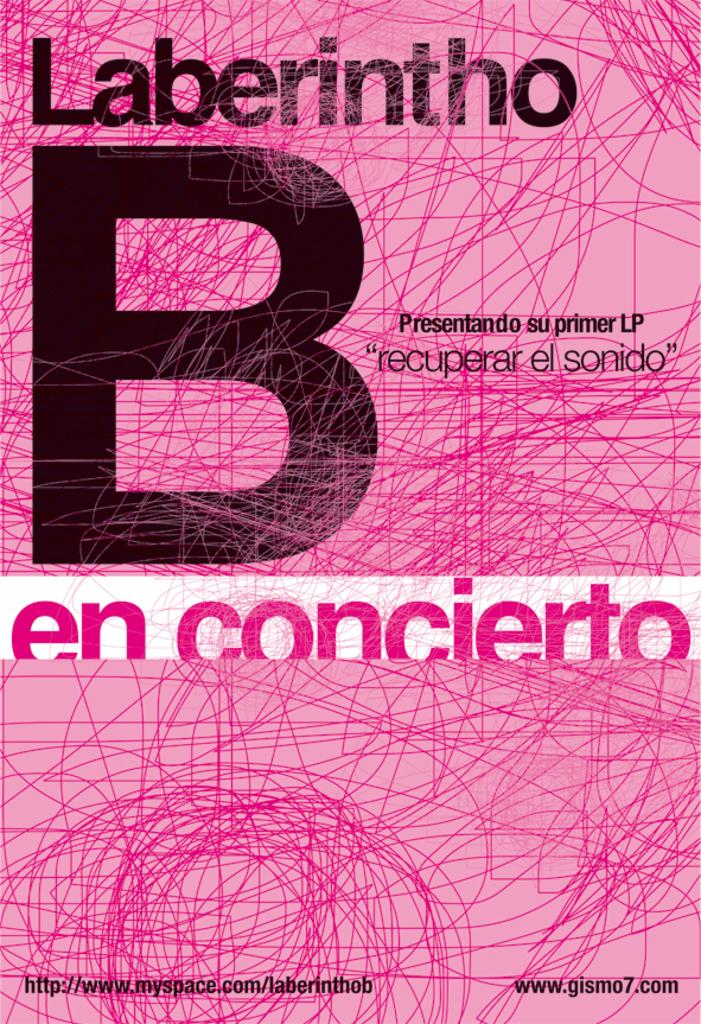<image>
Share a concise interpretation of the image provided. A book that reads laberintho and has a giant b on the cover as well. 